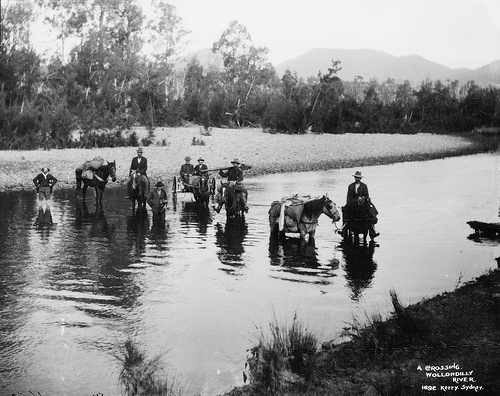Describe the objects in this image and their specific colors. I can see horse in gray, black, darkgray, and lightgray tones, horse in gray, black, darkgray, and lightgray tones, horse in gray, black, darkgray, and lightgray tones, horse in gray, black, darkgray, and lightgray tones, and horse in gray, black, darkgray, and lightgray tones in this image. 